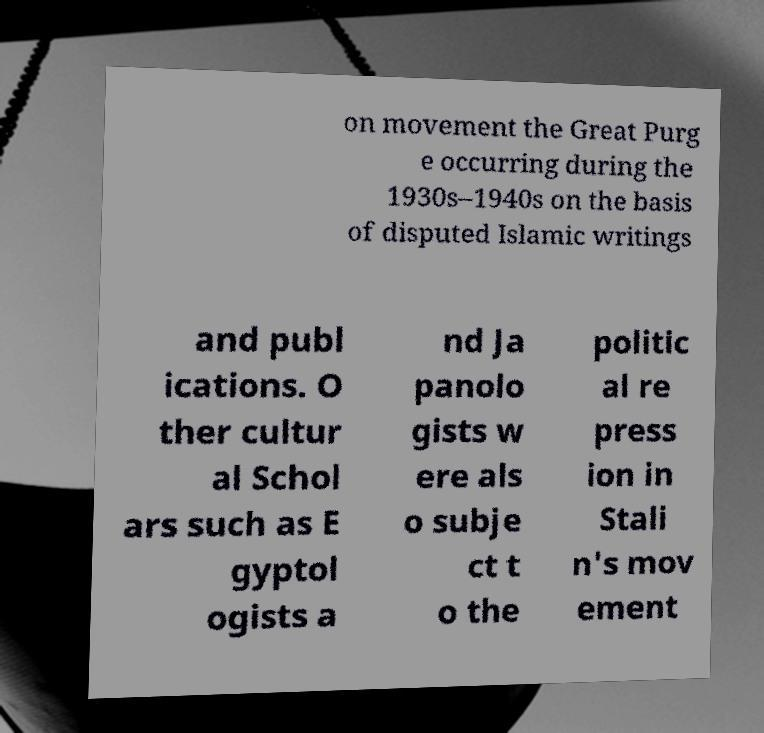Could you extract and type out the text from this image? on movement the Great Purg e occurring during the 1930s–1940s on the basis of disputed Islamic writings and publ ications. O ther cultur al Schol ars such as E gyptol ogists a nd Ja panolo gists w ere als o subje ct t o the politic al re press ion in Stali n's mov ement 